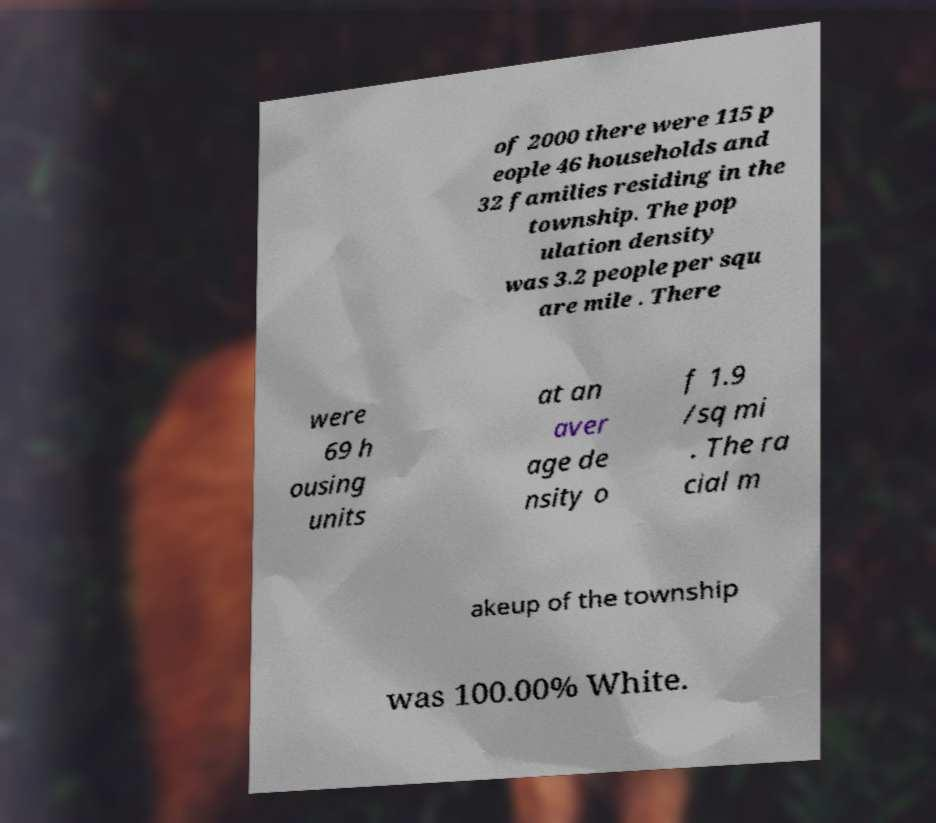Could you extract and type out the text from this image? of 2000 there were 115 p eople 46 households and 32 families residing in the township. The pop ulation density was 3.2 people per squ are mile . There were 69 h ousing units at an aver age de nsity o f 1.9 /sq mi . The ra cial m akeup of the township was 100.00% White. 